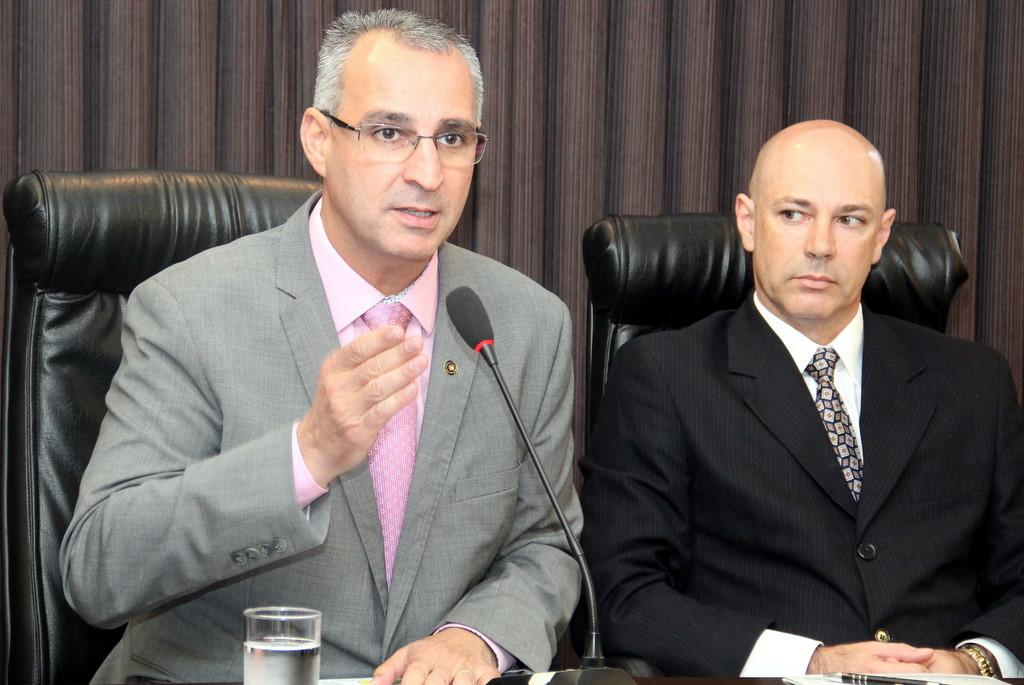How many people are in the image? There are two persons in the image. What are the persons doing in the image? The persons are sitting on chairs. What objects are in front of the persons? There is a mic, a glass with water, and a pen in front of them. What can be seen in the background of the image? There is a wall in the background of the image. What type of bells can be heard ringing in the image? There are no bells present in the image, and therefore no sound can be heard. What design is featured on the wall in the background? The provided facts do not mention any specific design on the wall in the background. --- Facts: 1. There is a car in the image. 2. The car is red. 3. The car has four wheels. 4. There is a road in the image. 5. The road is paved. Absurd Topics: parrot, ocean, mountain Conversation: What is the main subject of the image? The main subject of the image is a car. What color is the car? The car is red. How many wheels does the car have? The car has four wheels. What can be seen in the background of the image? There is a road in the image. What type of road is visible in the image? The road is paved. Reasoning: Let's think step by step in order to produce the conversation. We start by identifying the main subject of the image, which is the car. Then, we describe the car's color and the number of wheels it has. Next, we mention the road visible in the background, noting that it is paved. Absurd Question/Answer: Can you see a parrot flying over the car in the image? There is no parrot present in the image. What type of mountain can be seen in the background of the image? There is no mountain visible in the image; it features a car and a paved road. 